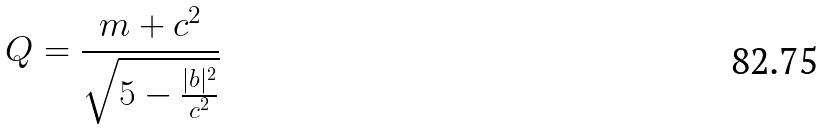Convert formula to latex. <formula><loc_0><loc_0><loc_500><loc_500>Q = \frac { m + c ^ { 2 } } { \sqrt { 5 - \frac { | b | ^ { 2 } } { c ^ { 2 } } } }</formula> 